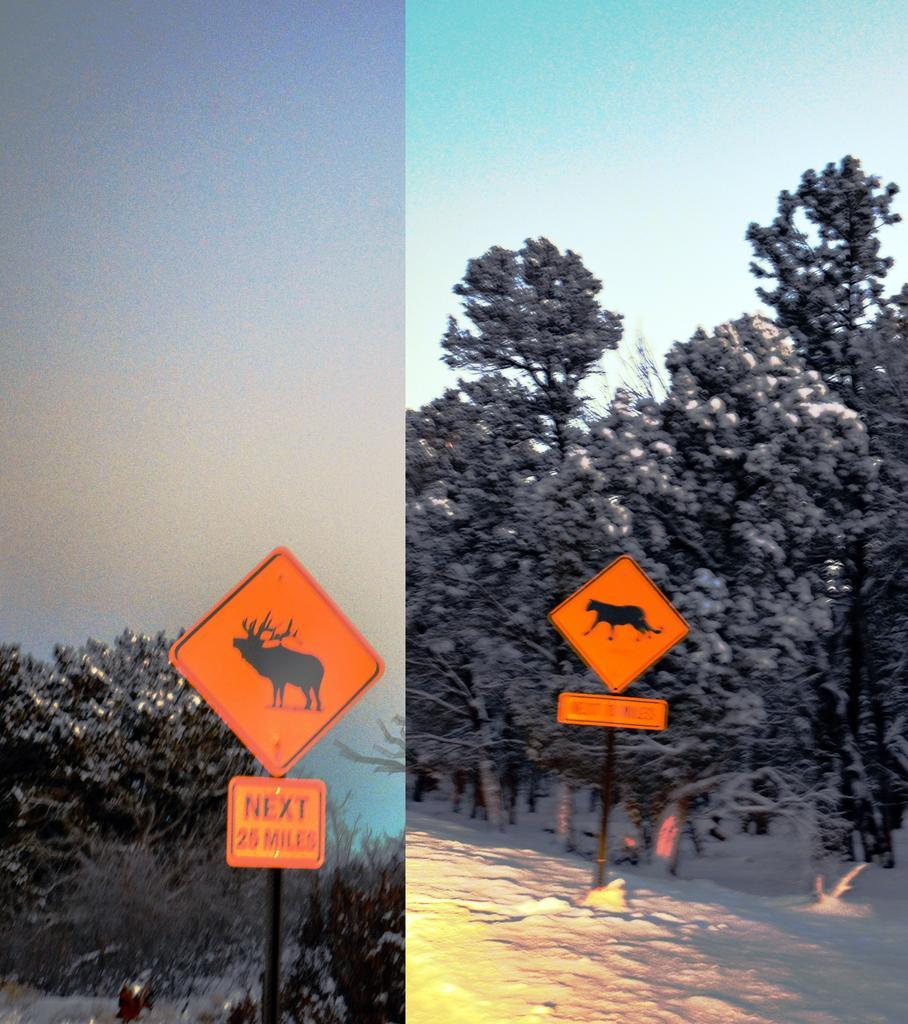Please provide a concise description of this image. In this image I can see there is the photo collage, there are sign boards in orange color. In the middle there are trees, at the top there is the sky. 